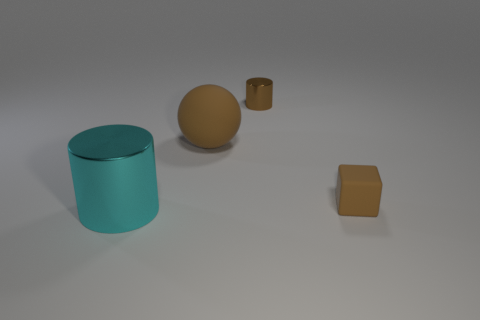Is there any other thing that is the same color as the big metal cylinder?
Provide a succinct answer. No. What is the color of the shiny object that is in front of the metallic cylinder that is on the right side of the large shiny object?
Your response must be concise. Cyan. What material is the brown object on the left side of the metallic cylinder that is behind the metal cylinder that is on the left side of the large rubber ball?
Offer a terse response. Rubber. How many blue shiny blocks are the same size as the sphere?
Provide a succinct answer. 0. There is a object that is both in front of the large brown ball and to the right of the big brown matte object; what material is it?
Keep it short and to the point. Rubber. What number of brown things are in front of the big cyan metallic thing?
Offer a very short reply. 0. Is the shape of the tiny brown rubber object the same as the large thing that is on the right side of the big cyan metallic object?
Keep it short and to the point. No. Are there any big cyan objects that have the same shape as the tiny matte thing?
Keep it short and to the point. No. There is a large thing that is on the right side of the metal cylinder that is in front of the rubber cube; what is its shape?
Provide a short and direct response. Sphere. There is a small brown object that is to the left of the small block; what is its shape?
Your answer should be very brief. Cylinder. 